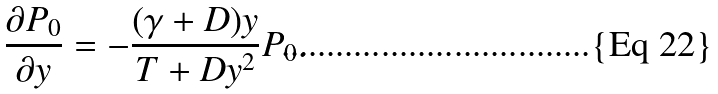<formula> <loc_0><loc_0><loc_500><loc_500>\frac { \partial P _ { 0 } } { \partial y } = - \frac { ( \gamma + D ) y } { T + D y ^ { 2 } } P _ { 0 } .</formula> 